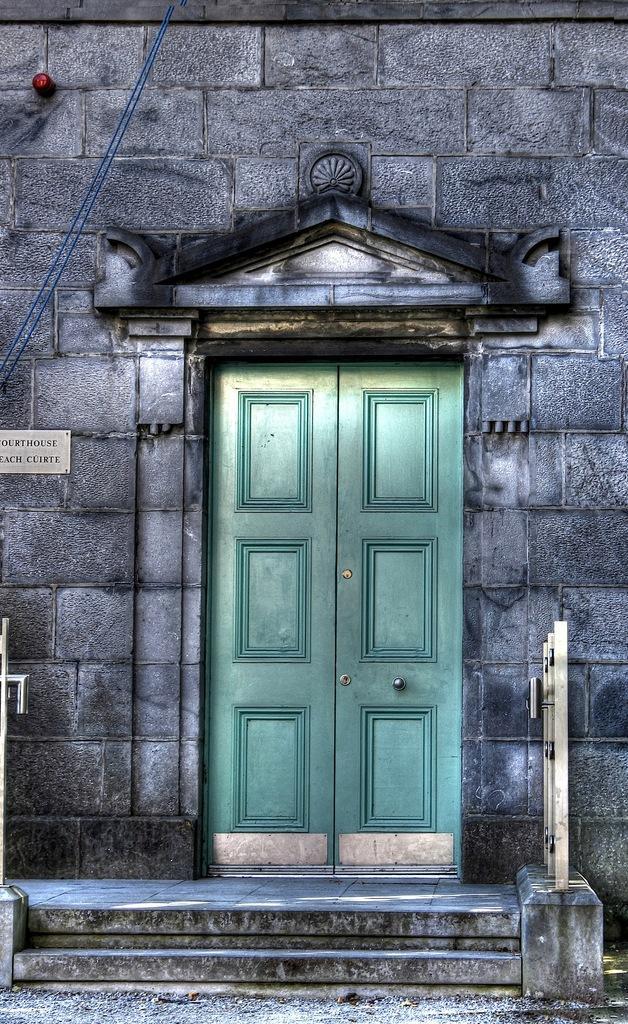Could you give a brief overview of what you see in this image? In this image we can see a door, a metal fence and some stairs. We can also see a name board on a wall and some wires. 